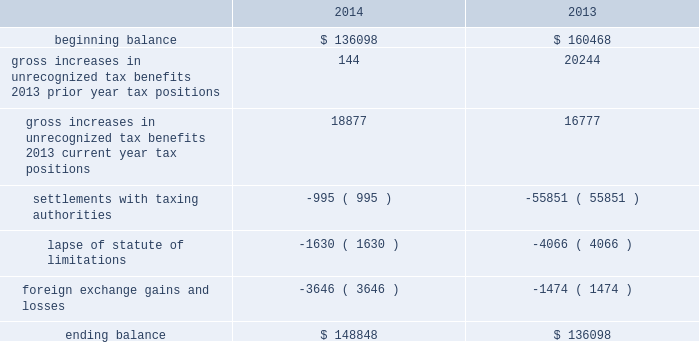Adobe systems incorporated notes to consolidated financial statements ( continued ) accounting for uncertainty in income taxes during fiscal 2014 and 2013 , our aggregate changes in our total gross amount of unrecognized tax benefits are summarized as follows ( in thousands ) : .
As of november 28 , 2014 , the combined amount of accrued interest and penalties related to tax positions taken on our tax returns and included in non-current income taxes payable was approximately $ 14.6 million .
We file income tax returns in the u.s .
On a federal basis and in many u.s .
State and foreign jurisdictions .
We are subject to the continual examination of our income tax returns by the irs and other domestic and foreign tax authorities .
Our major tax jurisdictions are ireland , california and the u.s .
For ireland , california and the u.s. , the earliest fiscal years open for examination are 2008 , 2008 and 2010 , respectively .
We regularly assess the likelihood of outcomes resulting from these examinations to determine the adequacy of our provision for income taxes and have reserved for potential adjustments that may result from the current examinations .
We believe such estimates to be reasonable ; however , there can be no assurance that the final determination of any of these examinations will not have an adverse effect on our operating results and financial position .
In july 2013 , a u.s .
Income tax examination covering fiscal 2008 and 2009 was completed .
Our accrued tax and interest related to these years was $ 48.4 million and was previously reported in long-term income taxes payable .
We settled the tax obligation resulting from this examination with cash and income tax assets totaling $ 41.2 million , and the resulting $ 7.2 million income tax benefit was recorded in the third quarter of fiscal 2013 .
The timing of the resolution of income tax examinations is highly uncertain as are the amounts and timing of tax payments that are part of any audit settlement process .
These events could cause large fluctuations in the balance sheet classification of current and non-current assets and liabilities .
We believe that within the next 12 months , it is reasonably possible that either certain audits will conclude or statutes of limitations on certain income tax examination periods will expire , or both .
Given the uncertainties described above , we can only determine a range of estimated potential decreases in underlying unrecognized tax benefits ranging from $ 0 to approximately $ 5 million .
Note 10 .
Restructuring fiscal 2014 restructuring plan in the fourth quarter of fiscal 2014 , in order to better align our global resources for digital media and digital marketing , we initiated a restructuring plan to vacate our research and development facility in china and our sales and marketing facility in russia .
This plan consisted of reductions of approximately 350 full-time positions and we recorded restructuring charges of approximately $ 18.8 million related to ongoing termination benefits for the positions eliminated .
During fiscal 2015 , we intend to vacate both of these facilities .
The amount accrued for the fair value of future contractual obligations under these operating leases was insignificant .
Other restructuring plans during the past several years , we have implemented other restructuring plans consisting of reductions in workforce and the consolidation of facilities to better align our resources around our business strategies .
As of november 28 , 2014 , we considered our other restructuring plans to be substantially complete .
We continue to make cash outlays to settle obligations under these plans , however the current impact to our consolidated financial statements is not significant. .
For the july 2013 settled tax obligation resulting from the examination , what percent was recorded in the third quarter of fiscal 2013? 
Computations: (7.2 / 41.2)
Answer: 0.17476. 